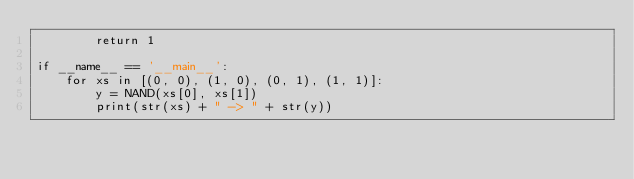<code> <loc_0><loc_0><loc_500><loc_500><_Python_>        return 1

if __name__ == '__main__':
    for xs in [(0, 0), (1, 0), (0, 1), (1, 1)]:
        y = NAND(xs[0], xs[1])
        print(str(xs) + " -> " + str(y))

</code> 